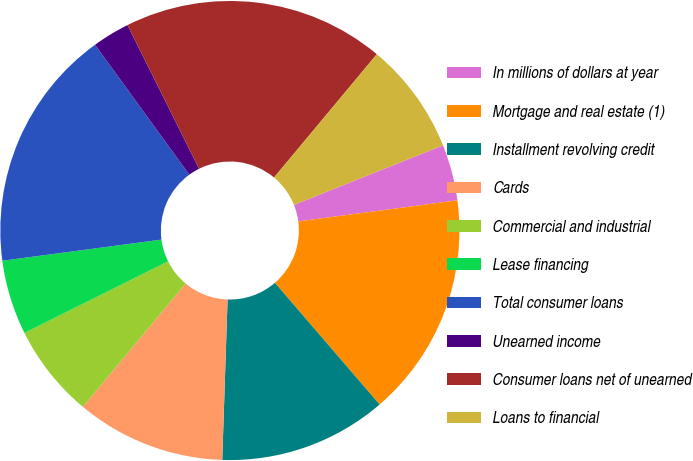Convert chart to OTSL. <chart><loc_0><loc_0><loc_500><loc_500><pie_chart><fcel>In millions of dollars at year<fcel>Mortgage and real estate (1)<fcel>Installment revolving credit<fcel>Cards<fcel>Commercial and industrial<fcel>Lease financing<fcel>Total consumer loans<fcel>Unearned income<fcel>Consumer loans net of unearned<fcel>Loans to financial<nl><fcel>3.95%<fcel>15.79%<fcel>11.84%<fcel>10.53%<fcel>6.58%<fcel>5.26%<fcel>17.11%<fcel>2.63%<fcel>18.42%<fcel>7.89%<nl></chart> 